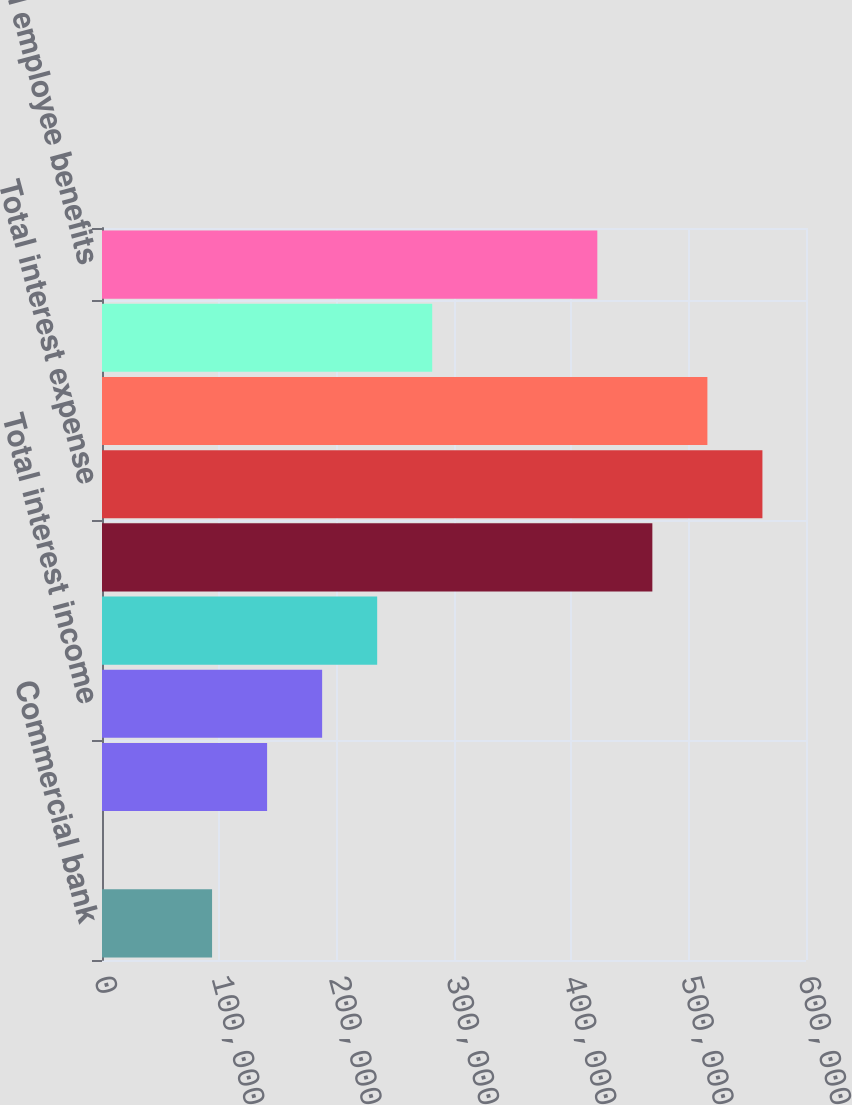Convert chart to OTSL. <chart><loc_0><loc_0><loc_500><loc_500><bar_chart><fcel>Commercial bank<fcel>Other subsidiaries<fcel>Other loans and securities<fcel>Total interest income<fcel>Affiliated trusts<fcel>Other borrowed funds<fcel>Total interest expense<fcel>Net interest loss<fcel>Other income<fcel>Salaries and employee benefits<nl><fcel>93812.4<fcel>3<fcel>140717<fcel>187622<fcel>234526<fcel>469050<fcel>562859<fcel>515955<fcel>281431<fcel>422145<nl></chart> 